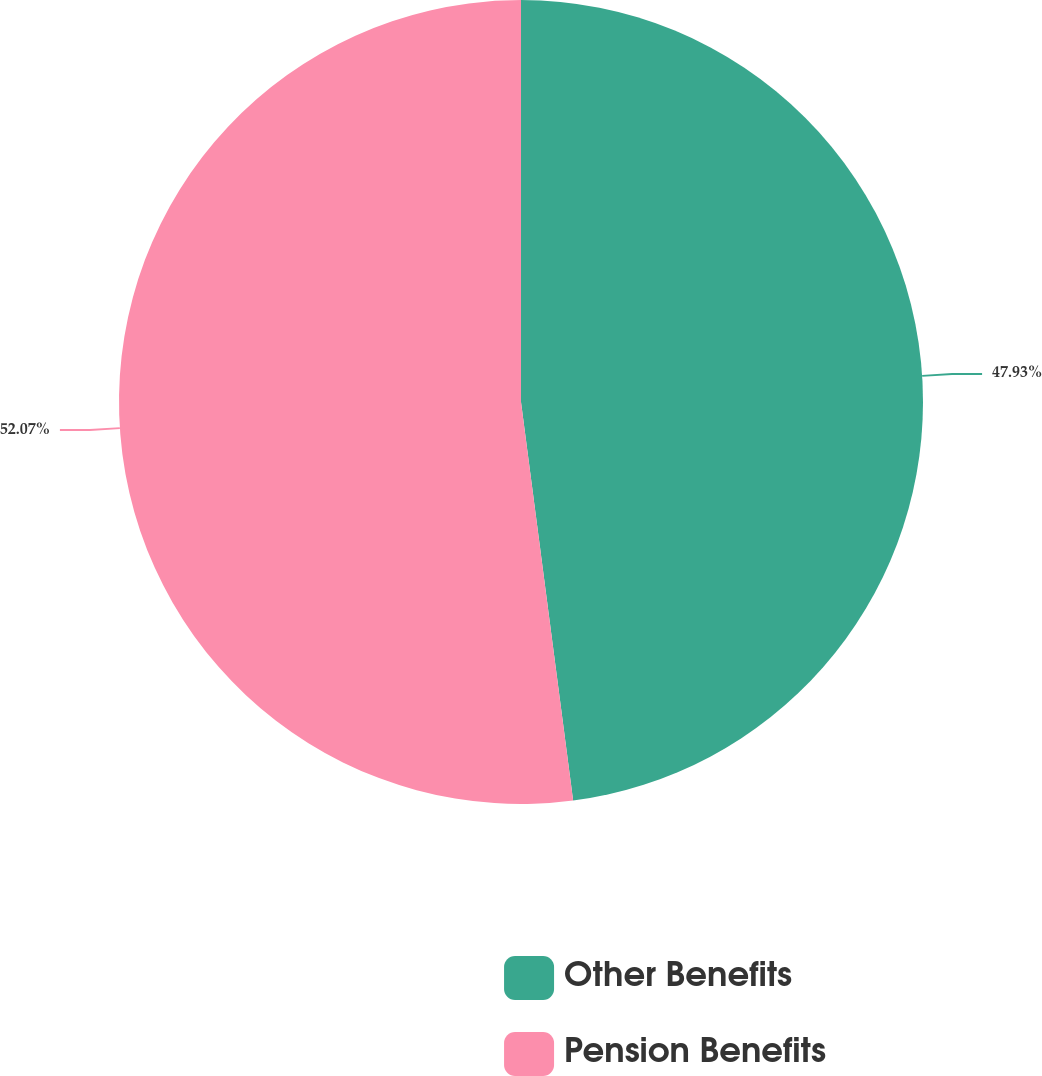Convert chart to OTSL. <chart><loc_0><loc_0><loc_500><loc_500><pie_chart><fcel>Other Benefits<fcel>Pension Benefits<nl><fcel>47.93%<fcel>52.07%<nl></chart> 